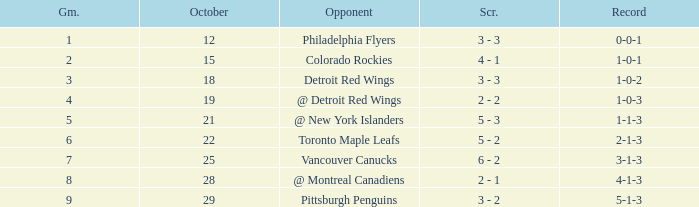Name the least game for record of 1-0-2 3.0. 